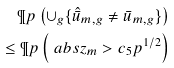Convert formula to latex. <formula><loc_0><loc_0><loc_500><loc_500>\P p \left ( \cup _ { g } \{ \hat { \bar { u } } _ { m , g } \neq \bar { u } _ { m , g } \} \right ) \\ \leq \P p \left ( \ a b s { z _ { m } } > c _ { 5 } p ^ { 1 / 2 } \right )</formula> 